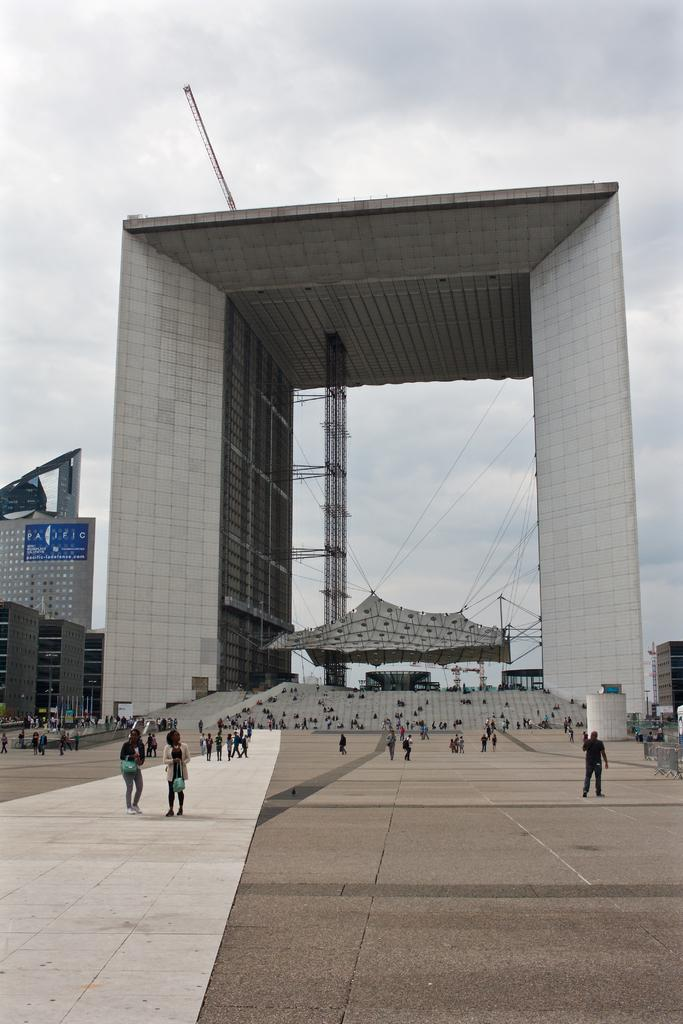What are the people in the image doing? The people in the image are walking on the road. What structures are tied to ropes in the image? There are tents tied to ropes in the image. What type of man-made structures can be seen in the image? Buildings are visible in the image. What is visible in the background of the image? The sky is visible in the background of the image. What can be observed in the sky in the image? Clouds are present in the sky. How does the image support world peace? The image does not directly support world peace; it simply depicts people walking on the road, tents tied to ropes, buildings, and clouds in the sky. 